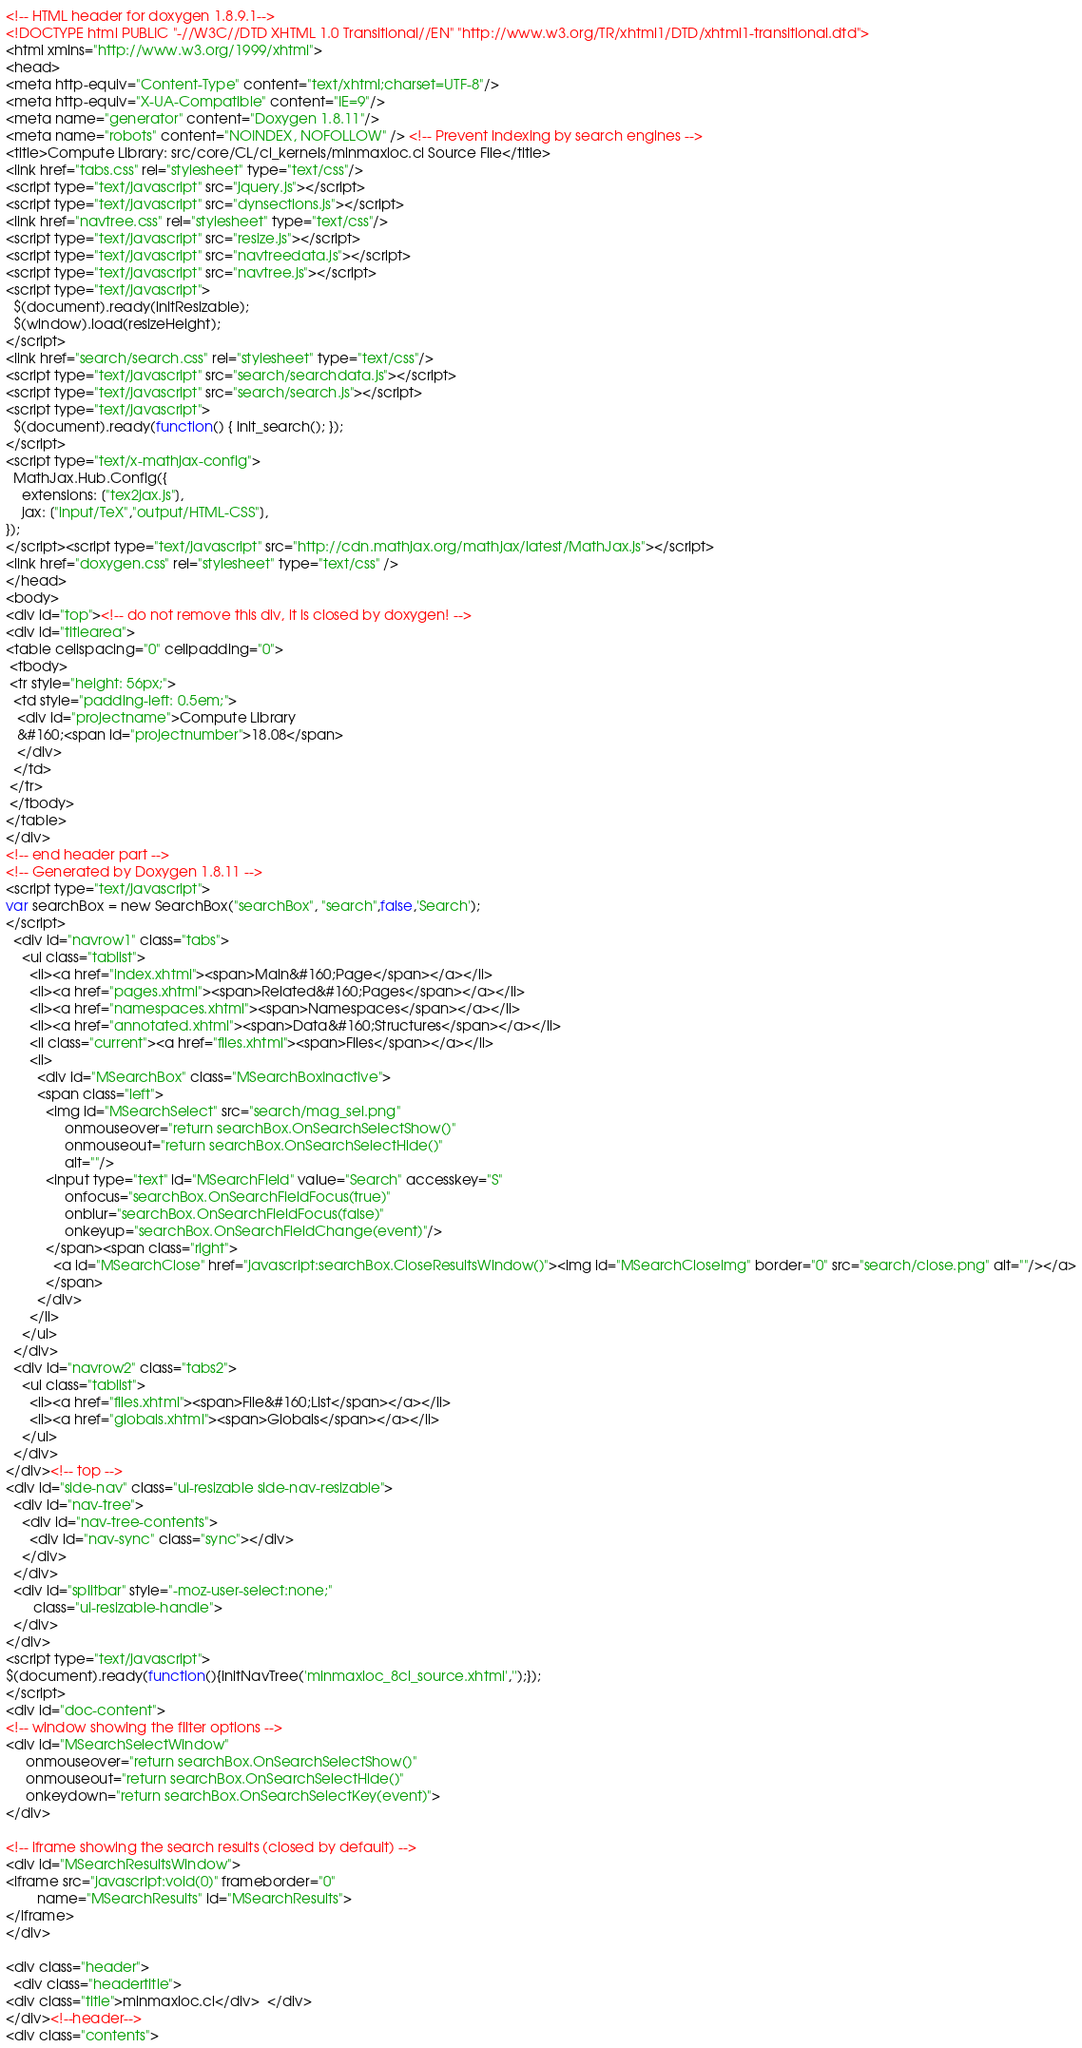<code> <loc_0><loc_0><loc_500><loc_500><_HTML_><!-- HTML header for doxygen 1.8.9.1-->
<!DOCTYPE html PUBLIC "-//W3C//DTD XHTML 1.0 Transitional//EN" "http://www.w3.org/TR/xhtml1/DTD/xhtml1-transitional.dtd">
<html xmlns="http://www.w3.org/1999/xhtml">
<head>
<meta http-equiv="Content-Type" content="text/xhtml;charset=UTF-8"/>
<meta http-equiv="X-UA-Compatible" content="IE=9"/>
<meta name="generator" content="Doxygen 1.8.11"/>
<meta name="robots" content="NOINDEX, NOFOLLOW" /> <!-- Prevent indexing by search engines -->
<title>Compute Library: src/core/CL/cl_kernels/minmaxloc.cl Source File</title>
<link href="tabs.css" rel="stylesheet" type="text/css"/>
<script type="text/javascript" src="jquery.js"></script>
<script type="text/javascript" src="dynsections.js"></script>
<link href="navtree.css" rel="stylesheet" type="text/css"/>
<script type="text/javascript" src="resize.js"></script>
<script type="text/javascript" src="navtreedata.js"></script>
<script type="text/javascript" src="navtree.js"></script>
<script type="text/javascript">
  $(document).ready(initResizable);
  $(window).load(resizeHeight);
</script>
<link href="search/search.css" rel="stylesheet" type="text/css"/>
<script type="text/javascript" src="search/searchdata.js"></script>
<script type="text/javascript" src="search/search.js"></script>
<script type="text/javascript">
  $(document).ready(function() { init_search(); });
</script>
<script type="text/x-mathjax-config">
  MathJax.Hub.Config({
    extensions: ["tex2jax.js"],
    jax: ["input/TeX","output/HTML-CSS"],
});
</script><script type="text/javascript" src="http://cdn.mathjax.org/mathjax/latest/MathJax.js"></script>
<link href="doxygen.css" rel="stylesheet" type="text/css" />
</head>
<body>
<div id="top"><!-- do not remove this div, it is closed by doxygen! -->
<div id="titlearea">
<table cellspacing="0" cellpadding="0">
 <tbody>
 <tr style="height: 56px;">
  <td style="padding-left: 0.5em;">
   <div id="projectname">Compute Library
   &#160;<span id="projectnumber">18.08</span>
   </div>
  </td>
 </tr>
 </tbody>
</table>
</div>
<!-- end header part -->
<!-- Generated by Doxygen 1.8.11 -->
<script type="text/javascript">
var searchBox = new SearchBox("searchBox", "search",false,'Search');
</script>
  <div id="navrow1" class="tabs">
    <ul class="tablist">
      <li><a href="index.xhtml"><span>Main&#160;Page</span></a></li>
      <li><a href="pages.xhtml"><span>Related&#160;Pages</span></a></li>
      <li><a href="namespaces.xhtml"><span>Namespaces</span></a></li>
      <li><a href="annotated.xhtml"><span>Data&#160;Structures</span></a></li>
      <li class="current"><a href="files.xhtml"><span>Files</span></a></li>
      <li>
        <div id="MSearchBox" class="MSearchBoxInactive">
        <span class="left">
          <img id="MSearchSelect" src="search/mag_sel.png"
               onmouseover="return searchBox.OnSearchSelectShow()"
               onmouseout="return searchBox.OnSearchSelectHide()"
               alt=""/>
          <input type="text" id="MSearchField" value="Search" accesskey="S"
               onfocus="searchBox.OnSearchFieldFocus(true)" 
               onblur="searchBox.OnSearchFieldFocus(false)" 
               onkeyup="searchBox.OnSearchFieldChange(event)"/>
          </span><span class="right">
            <a id="MSearchClose" href="javascript:searchBox.CloseResultsWindow()"><img id="MSearchCloseImg" border="0" src="search/close.png" alt=""/></a>
          </span>
        </div>
      </li>
    </ul>
  </div>
  <div id="navrow2" class="tabs2">
    <ul class="tablist">
      <li><a href="files.xhtml"><span>File&#160;List</span></a></li>
      <li><a href="globals.xhtml"><span>Globals</span></a></li>
    </ul>
  </div>
</div><!-- top -->
<div id="side-nav" class="ui-resizable side-nav-resizable">
  <div id="nav-tree">
    <div id="nav-tree-contents">
      <div id="nav-sync" class="sync"></div>
    </div>
  </div>
  <div id="splitbar" style="-moz-user-select:none;" 
       class="ui-resizable-handle">
  </div>
</div>
<script type="text/javascript">
$(document).ready(function(){initNavTree('minmaxloc_8cl_source.xhtml','');});
</script>
<div id="doc-content">
<!-- window showing the filter options -->
<div id="MSearchSelectWindow"
     onmouseover="return searchBox.OnSearchSelectShow()"
     onmouseout="return searchBox.OnSearchSelectHide()"
     onkeydown="return searchBox.OnSearchSelectKey(event)">
</div>

<!-- iframe showing the search results (closed by default) -->
<div id="MSearchResultsWindow">
<iframe src="javascript:void(0)" frameborder="0" 
        name="MSearchResults" id="MSearchResults">
</iframe>
</div>

<div class="header">
  <div class="headertitle">
<div class="title">minmaxloc.cl</div>  </div>
</div><!--header-->
<div class="contents"></code> 